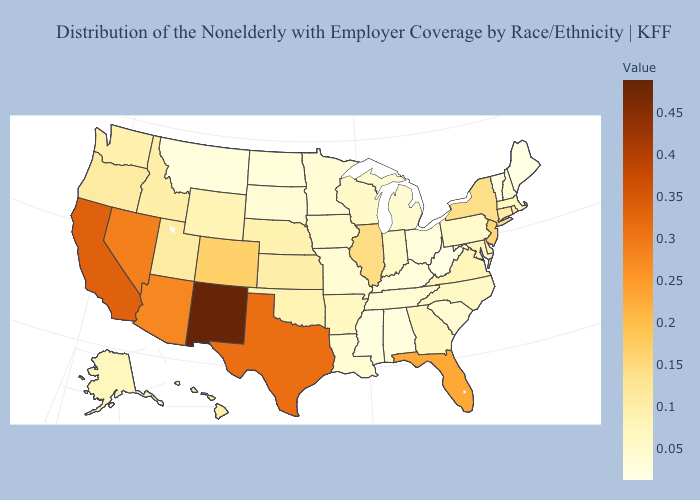Is the legend a continuous bar?
Short answer required. Yes. Does Kansas have a lower value than New Hampshire?
Keep it brief. No. Does Massachusetts have the lowest value in the Northeast?
Short answer required. No. Does West Virginia have the lowest value in the USA?
Give a very brief answer. Yes. Which states have the highest value in the USA?
Keep it brief. New Mexico. Among the states that border Pennsylvania , which have the highest value?
Give a very brief answer. New Jersey. Among the states that border North Carolina , does Georgia have the highest value?
Keep it brief. No. 